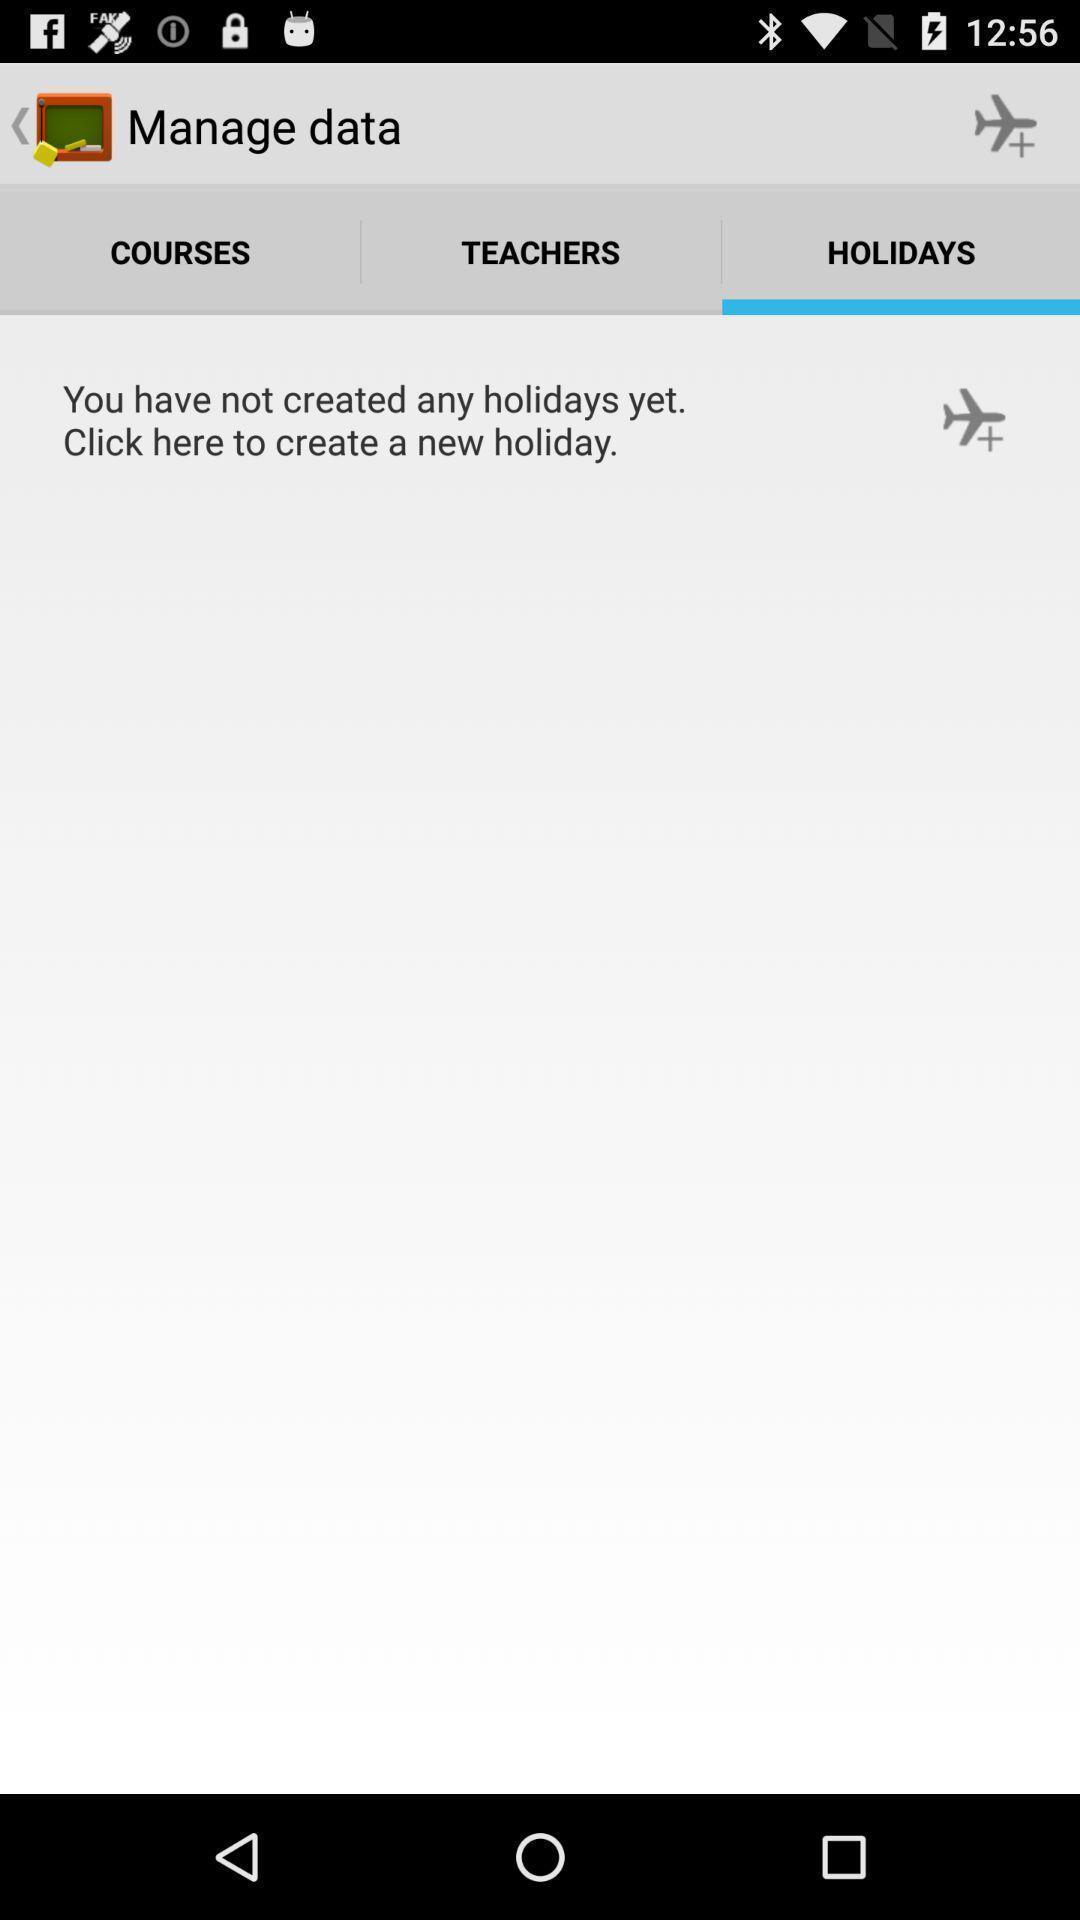Give me a summary of this screen capture. Screen displaying holidays page. 